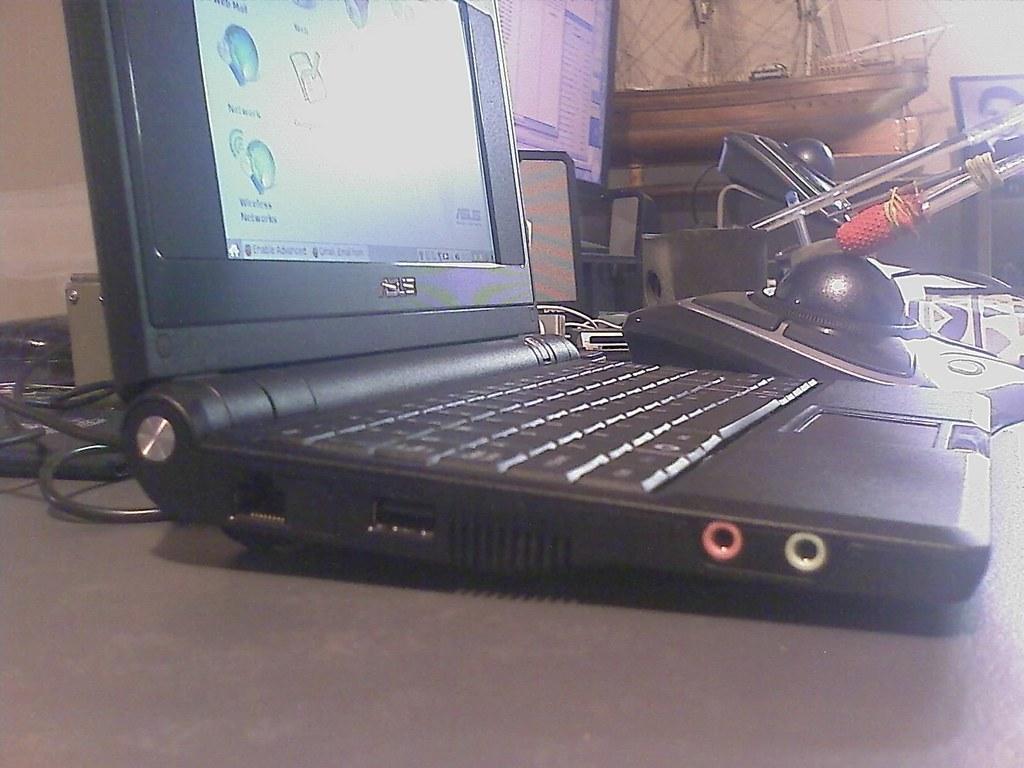Describe this image in one or two sentences. In this image we can see a table and on the table there are laptop, cables, photo frame and decors. 